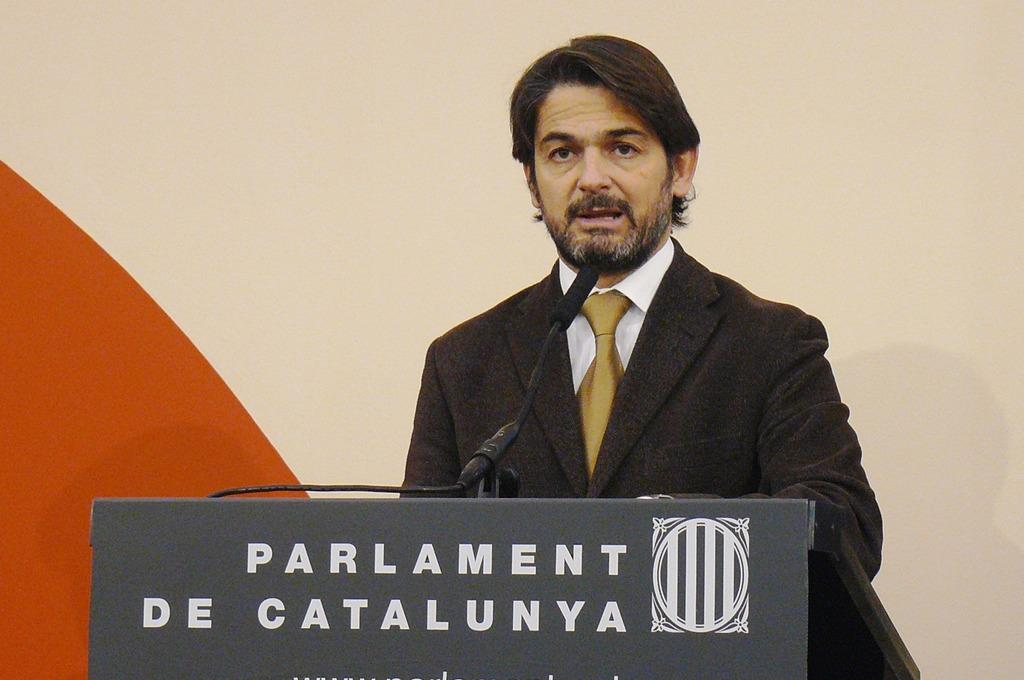What is the person in the image doing? The person is standing at a desk in the image. What object is on the desk with the person? There is a microphone (mic) on the desk. What can be seen behind the person in the image? There is a wall in the background of the image. What type of quartz is being used as a paperweight on the desk in the image? There is no quartz present in the image; the only object mentioned on the desk is a microphone. 